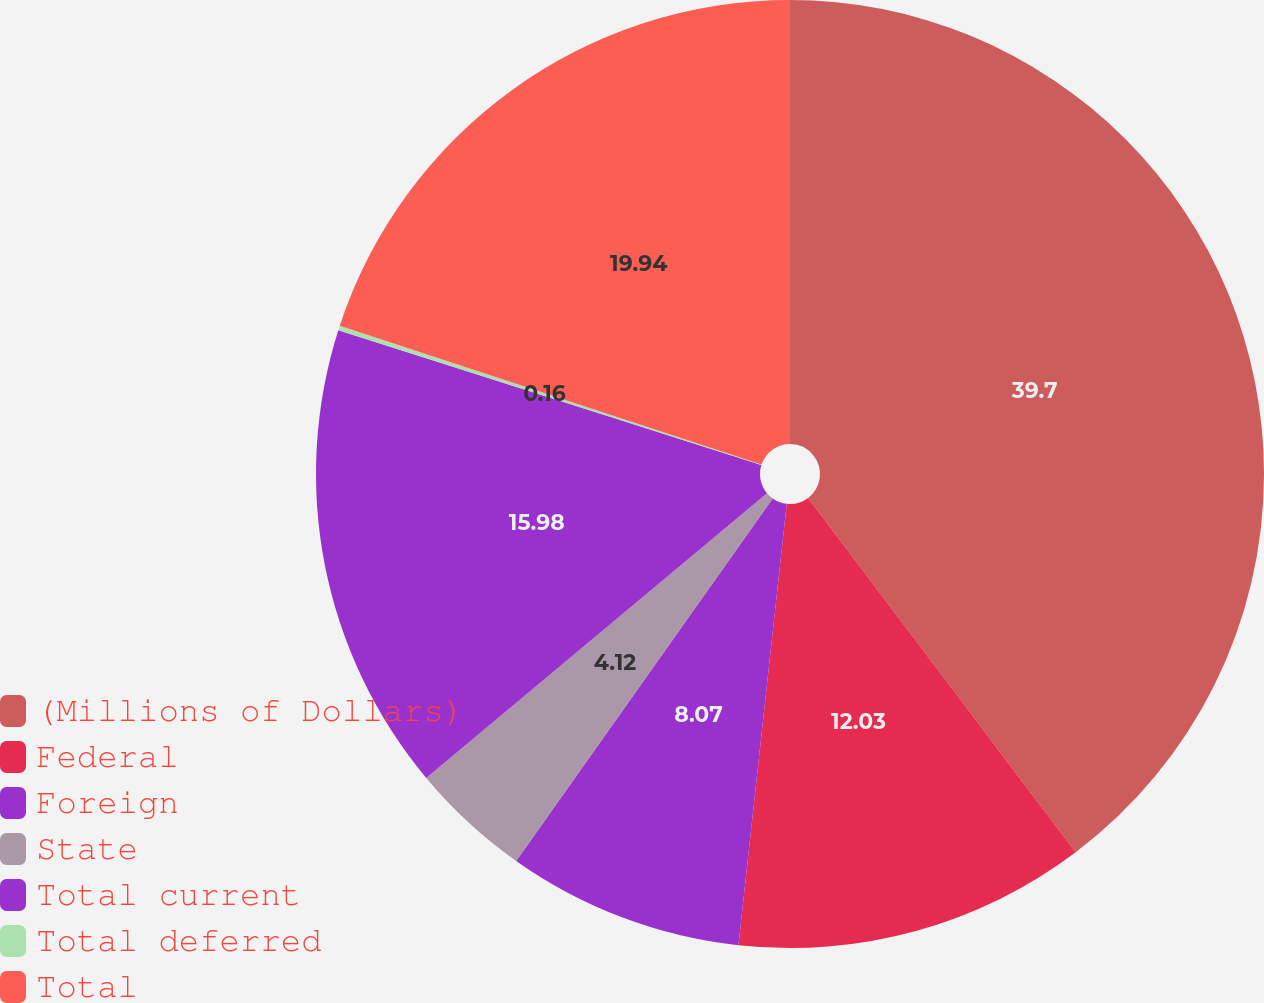<chart> <loc_0><loc_0><loc_500><loc_500><pie_chart><fcel>(Millions of Dollars)<fcel>Federal<fcel>Foreign<fcel>State<fcel>Total current<fcel>Total deferred<fcel>Total<nl><fcel>39.71%<fcel>12.03%<fcel>8.07%<fcel>4.12%<fcel>15.98%<fcel>0.16%<fcel>19.94%<nl></chart> 